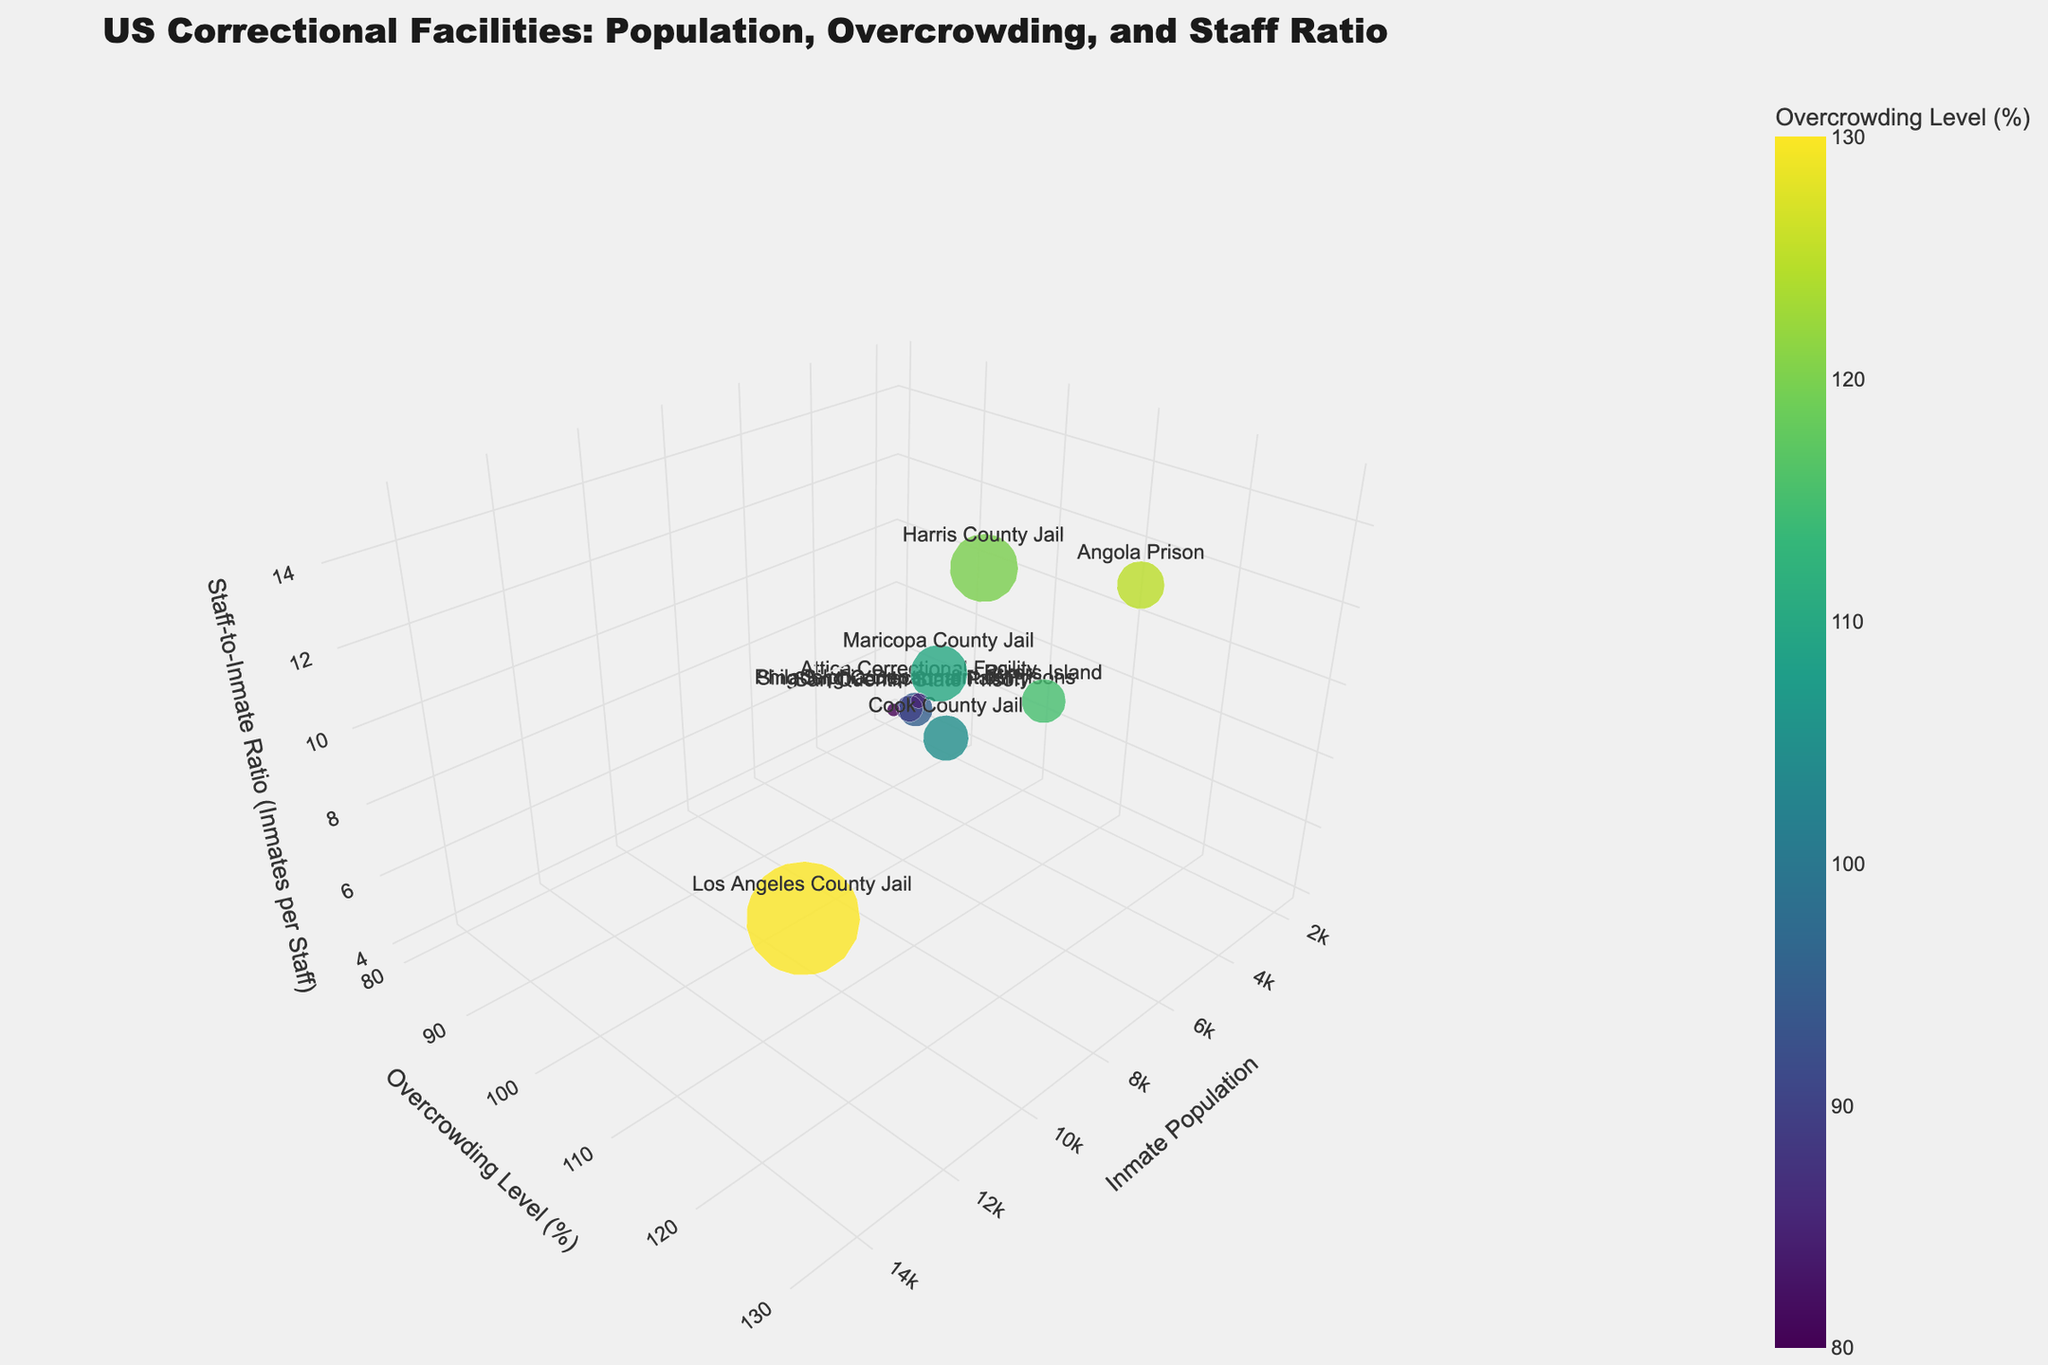How many facilities have overcrowding levels above 100%? Look for bubbles with a color intensity indicating overcrowding levels above 100% and count them.
Answer: 6 Which facility has the highest inmate population? Identify the bubble with the largest size, which indicates the highest inmate population.
Answer: Los Angeles County Jail What is the staff-to-inmate ratio at Rikers Island? Find Rikers Island and read off the z-axis value for staff-to-inmate ratio.
Answer: 1:10 Which facility has the lowest overcrowding level? Identify the bubble with the least intense color and check its overcrowding level value.
Answer: Sing Sing Correctional Facility What's the title of the chart? Look at the top of the chart where the title is displayed.
Answer: US Correctional Facilities: Population, Overcrowding, and Staff Ratio Which facility has the smallest inmate population? Identify the smallest bubble in the chart and read its label to find the facility name.
Answer: Sing Sing Correctional Facility Which facility has a higher staff-to-inmate ratio, Cook County Jail or Harris County Jail? Compare the z-axis values for Cook County Jail and Harris County Jail to see which is higher.
Answer: Cook County Jail Among the facilities with inmate populations above 7000, which one has the highest overcrowding level? Filter bubbles with inmate populations above 7000 and compare their colors to find the highest overcrowding level.
Answer: Los Angeles County Jail If you combine the inmate populations of the two facilities with the smallest populations, what is the total? Sum the inmate populations of the two smallest bubbles, Sing Sing Correctional Facility (1700) and Attica Correctional Facility (2000).
Answer: 3700 Which color scale is used to represent overcrowding levels? Look at the color legend on the chart to identify the color scale name.
Answer: Viridis 